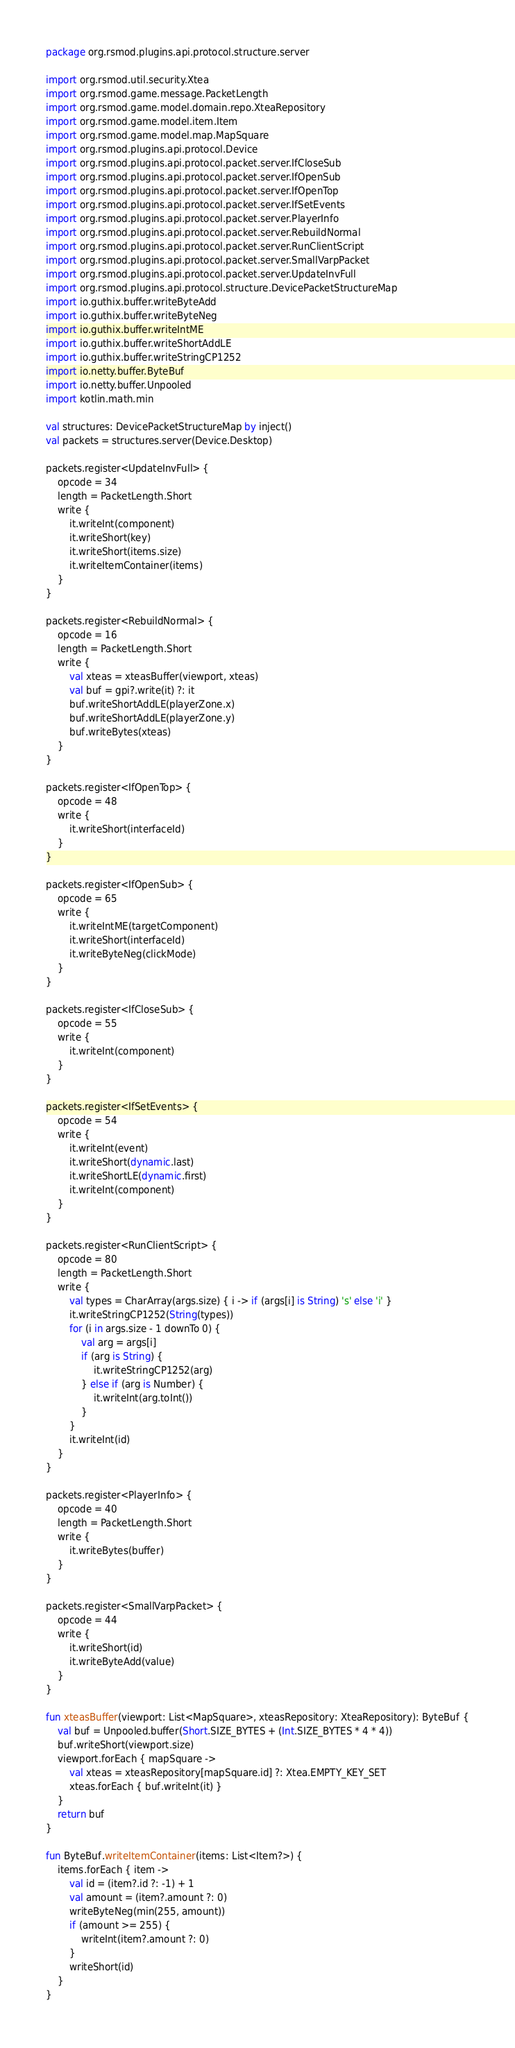<code> <loc_0><loc_0><loc_500><loc_500><_Kotlin_>package org.rsmod.plugins.api.protocol.structure.server

import org.rsmod.util.security.Xtea
import org.rsmod.game.message.PacketLength
import org.rsmod.game.model.domain.repo.XteaRepository
import org.rsmod.game.model.item.Item
import org.rsmod.game.model.map.MapSquare
import org.rsmod.plugins.api.protocol.Device
import org.rsmod.plugins.api.protocol.packet.server.IfCloseSub
import org.rsmod.plugins.api.protocol.packet.server.IfOpenSub
import org.rsmod.plugins.api.protocol.packet.server.IfOpenTop
import org.rsmod.plugins.api.protocol.packet.server.IfSetEvents
import org.rsmod.plugins.api.protocol.packet.server.PlayerInfo
import org.rsmod.plugins.api.protocol.packet.server.RebuildNormal
import org.rsmod.plugins.api.protocol.packet.server.RunClientScript
import org.rsmod.plugins.api.protocol.packet.server.SmallVarpPacket
import org.rsmod.plugins.api.protocol.packet.server.UpdateInvFull
import org.rsmod.plugins.api.protocol.structure.DevicePacketStructureMap
import io.guthix.buffer.writeByteAdd
import io.guthix.buffer.writeByteNeg
import io.guthix.buffer.writeIntME
import io.guthix.buffer.writeShortAddLE
import io.guthix.buffer.writeStringCP1252
import io.netty.buffer.ByteBuf
import io.netty.buffer.Unpooled
import kotlin.math.min

val structures: DevicePacketStructureMap by inject()
val packets = structures.server(Device.Desktop)

packets.register<UpdateInvFull> {
    opcode = 34
    length = PacketLength.Short
    write {
        it.writeInt(component)
        it.writeShort(key)
        it.writeShort(items.size)
        it.writeItemContainer(items)
    }
}

packets.register<RebuildNormal> {
    opcode = 16
    length = PacketLength.Short
    write {
        val xteas = xteasBuffer(viewport, xteas)
        val buf = gpi?.write(it) ?: it
        buf.writeShortAddLE(playerZone.x)
        buf.writeShortAddLE(playerZone.y)
        buf.writeBytes(xteas)
    }
}

packets.register<IfOpenTop> {
    opcode = 48
    write {
        it.writeShort(interfaceId)
    }
}

packets.register<IfOpenSub> {
    opcode = 65
    write {
        it.writeIntME(targetComponent)
        it.writeShort(interfaceId)
        it.writeByteNeg(clickMode)
    }
}

packets.register<IfCloseSub> {
    opcode = 55
    write {
        it.writeInt(component)
    }
}

packets.register<IfSetEvents> {
    opcode = 54
    write {
        it.writeInt(event)
        it.writeShort(dynamic.last)
        it.writeShortLE(dynamic.first)
        it.writeInt(component)
    }
}

packets.register<RunClientScript> {
    opcode = 80
    length = PacketLength.Short
    write {
        val types = CharArray(args.size) { i -> if (args[i] is String) 's' else 'i' }
        it.writeStringCP1252(String(types))
        for (i in args.size - 1 downTo 0) {
            val arg = args[i]
            if (arg is String) {
                it.writeStringCP1252(arg)
            } else if (arg is Number) {
                it.writeInt(arg.toInt())
            }
        }
        it.writeInt(id)
    }
}

packets.register<PlayerInfo> {
    opcode = 40
    length = PacketLength.Short
    write {
        it.writeBytes(buffer)
    }
}

packets.register<SmallVarpPacket> {
    opcode = 44
    write {
        it.writeShort(id)
        it.writeByteAdd(value)
    }
}

fun xteasBuffer(viewport: List<MapSquare>, xteasRepository: XteaRepository): ByteBuf {
    val buf = Unpooled.buffer(Short.SIZE_BYTES + (Int.SIZE_BYTES * 4 * 4))
    buf.writeShort(viewport.size)
    viewport.forEach { mapSquare ->
        val xteas = xteasRepository[mapSquare.id] ?: Xtea.EMPTY_KEY_SET
        xteas.forEach { buf.writeInt(it) }
    }
    return buf
}

fun ByteBuf.writeItemContainer(items: List<Item?>) {
    items.forEach { item ->
        val id = (item?.id ?: -1) + 1
        val amount = (item?.amount ?: 0)
        writeByteNeg(min(255, amount))
        if (amount >= 255) {
            writeInt(item?.amount ?: 0)
        }
        writeShort(id)
    }
}
</code> 